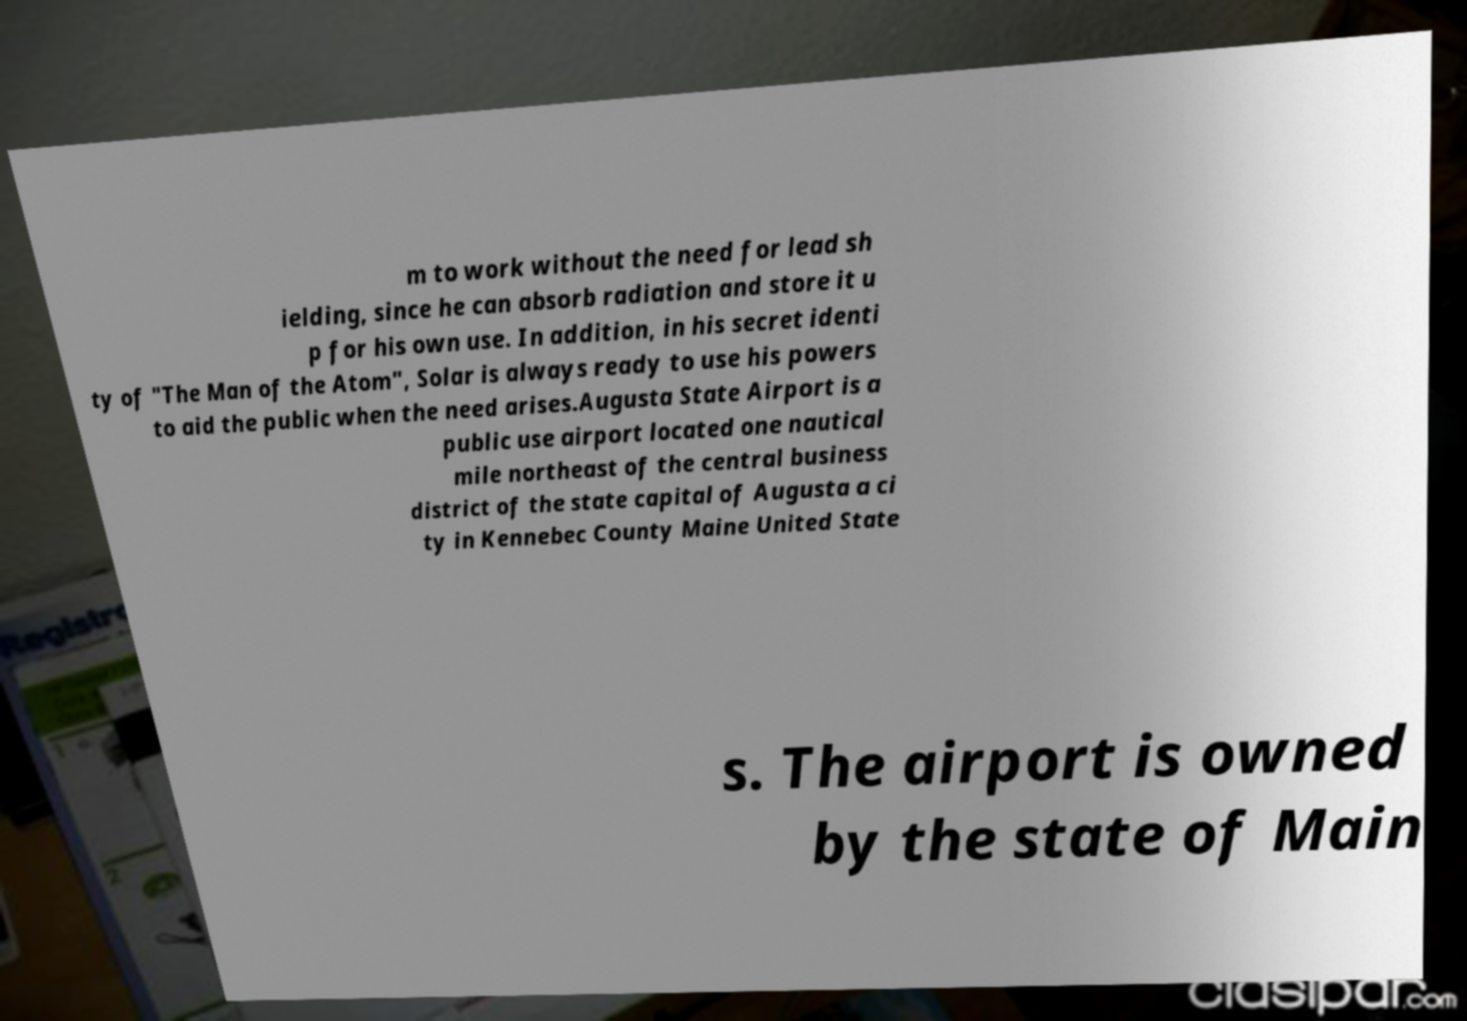I need the written content from this picture converted into text. Can you do that? m to work without the need for lead sh ielding, since he can absorb radiation and store it u p for his own use. In addition, in his secret identi ty of "The Man of the Atom", Solar is always ready to use his powers to aid the public when the need arises.Augusta State Airport is a public use airport located one nautical mile northeast of the central business district of the state capital of Augusta a ci ty in Kennebec County Maine United State s. The airport is owned by the state of Main 